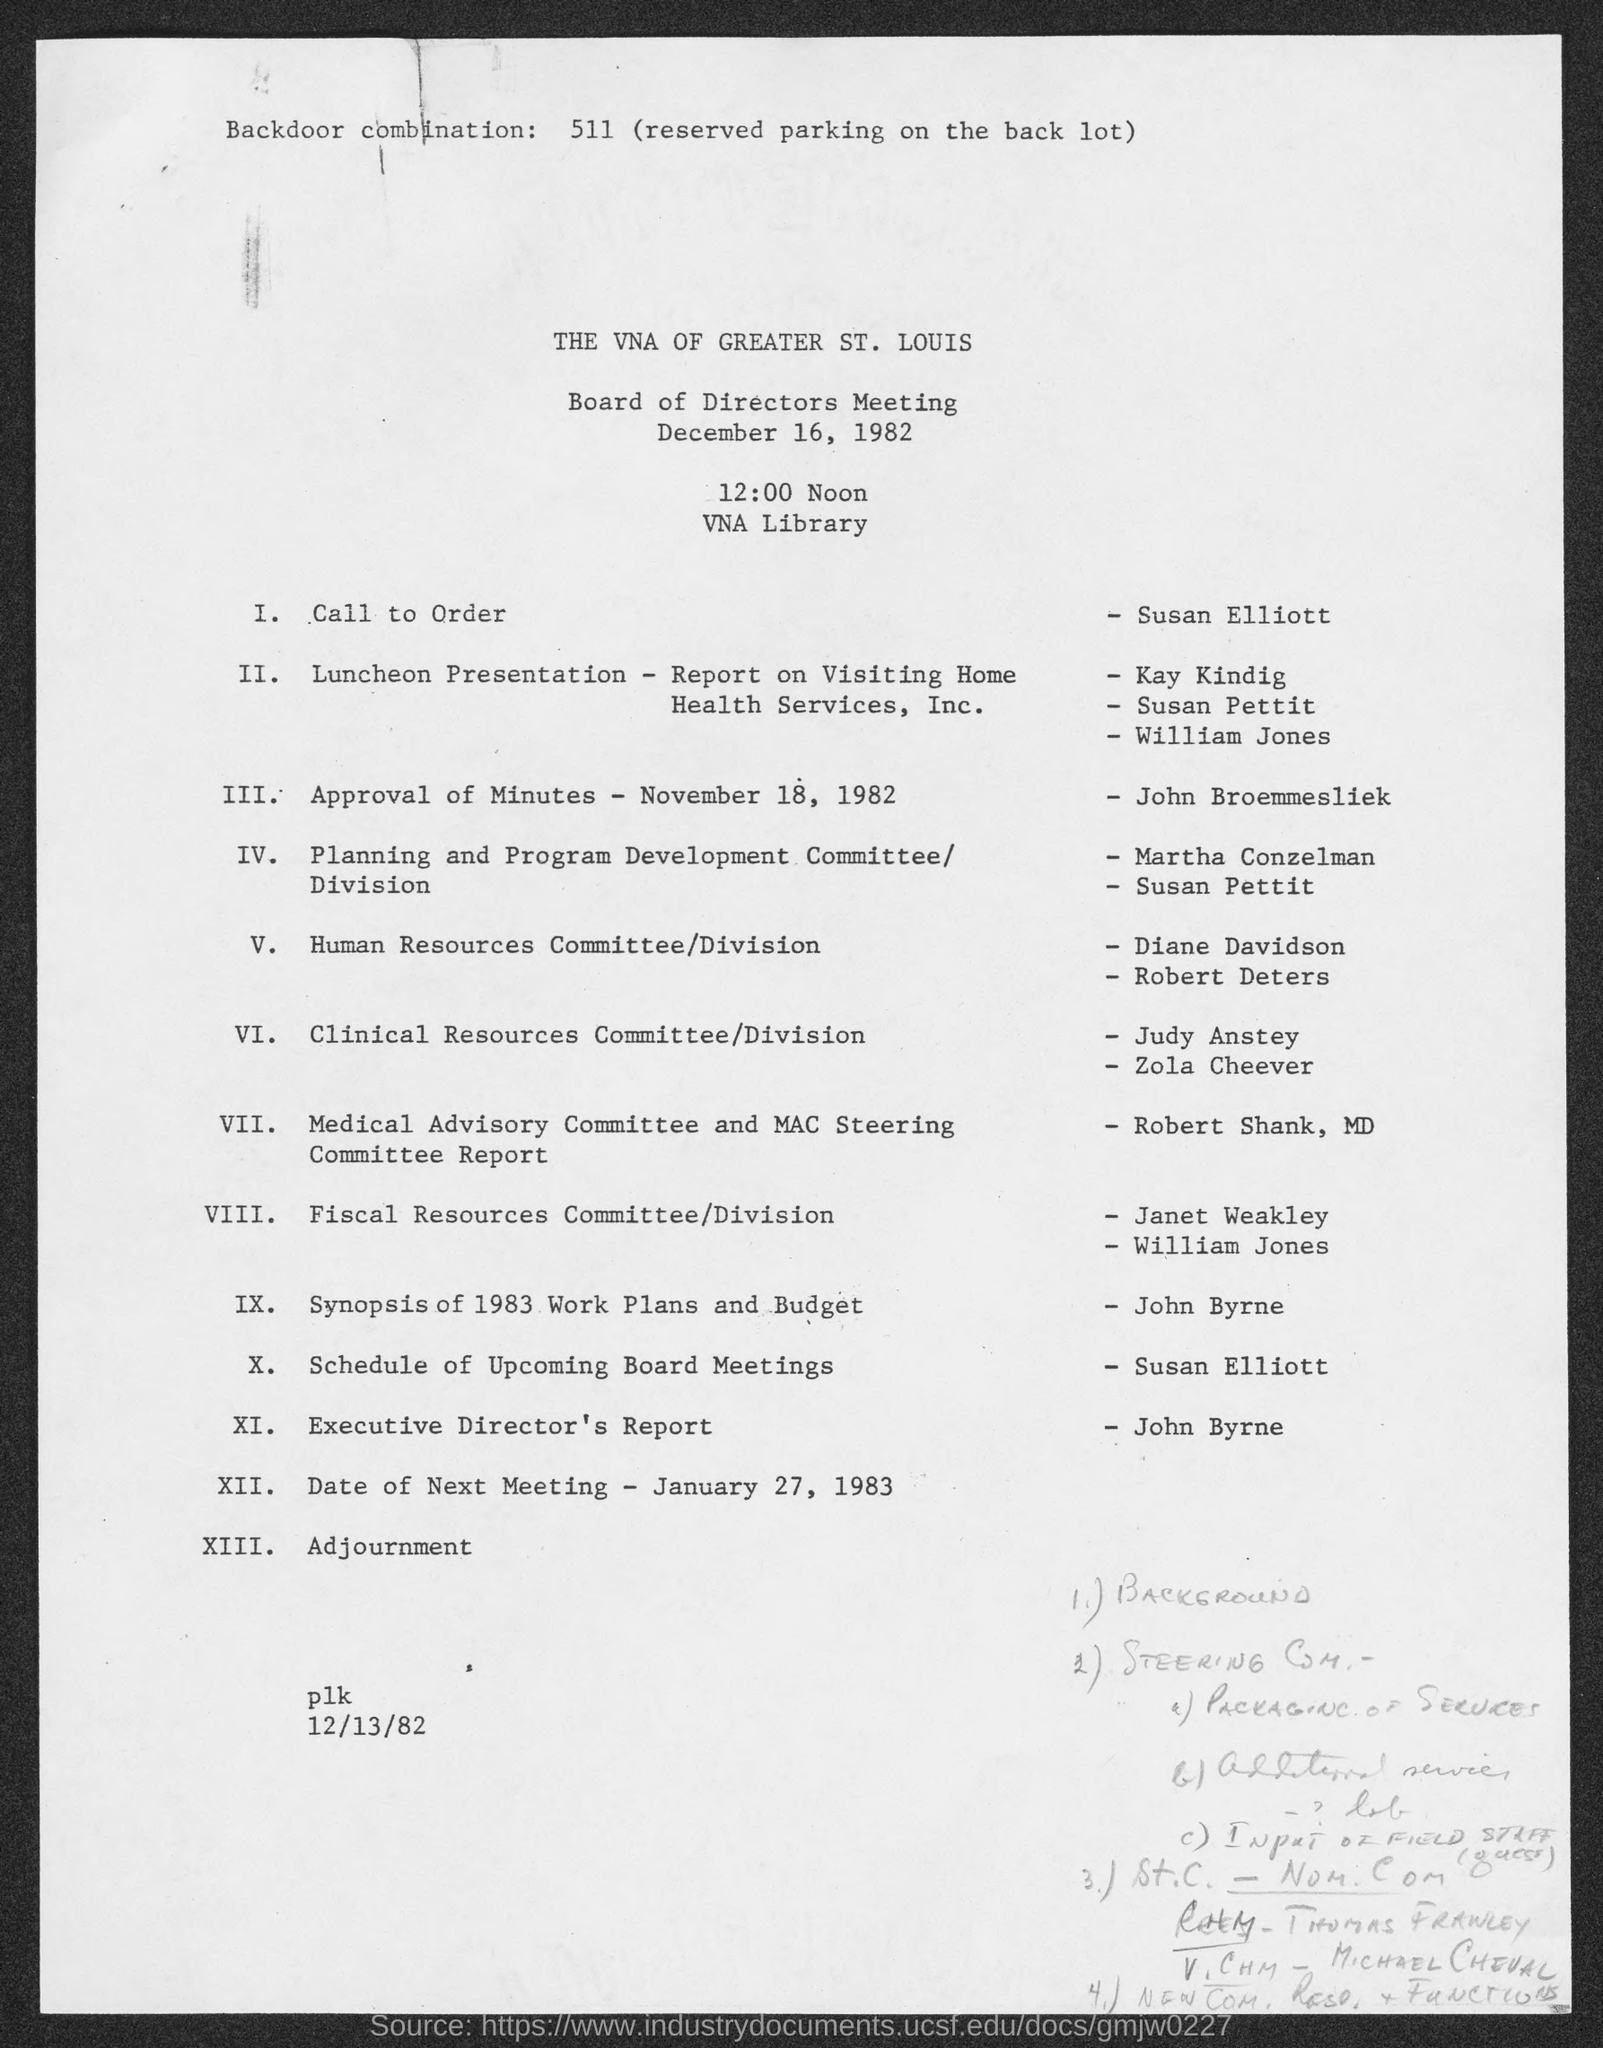Where is the Board of Directors Meeting organized?
Your answer should be very brief. VNA Library. Who is presenting the session on the schedule of upcoming board meetings?
Provide a succinct answer. Susan Elliott. What is the date of next meeting as per the agenda?
Your response must be concise. January 27, 1983. 